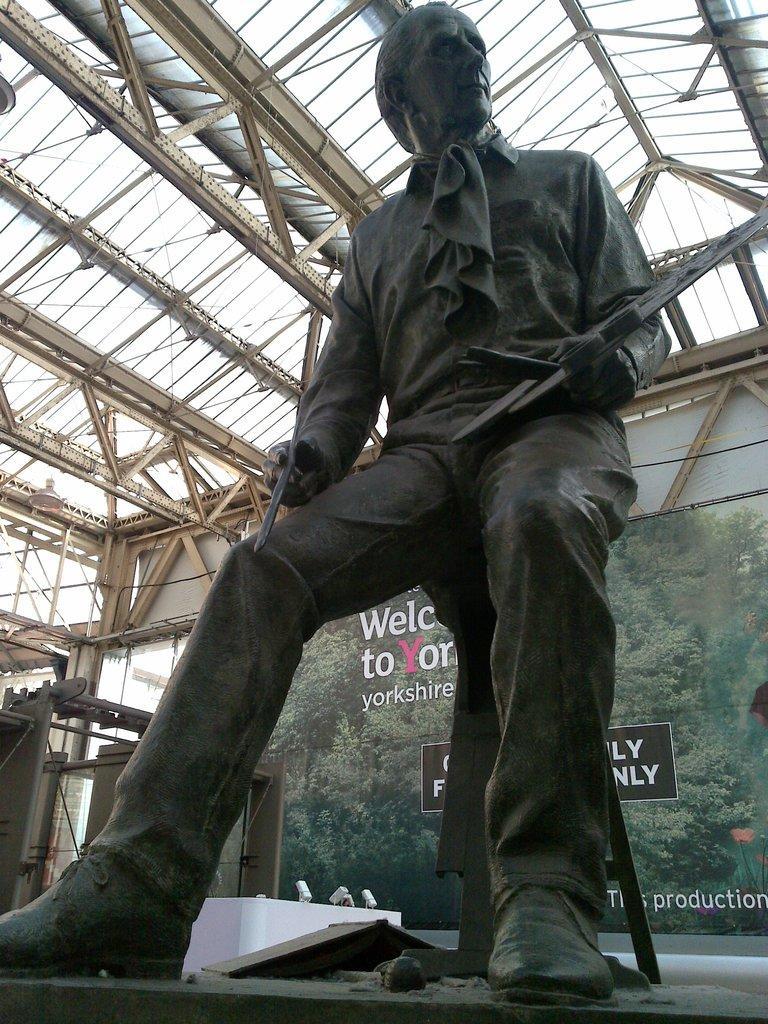Describe this image in one or two sentences. In this image we can see a sculpture of a person. Behind the sculpture we can see a banner with text and image. In the image we can see a group of trees. At the top we can see the roof. On the left side, we can see a light and a few objects. 